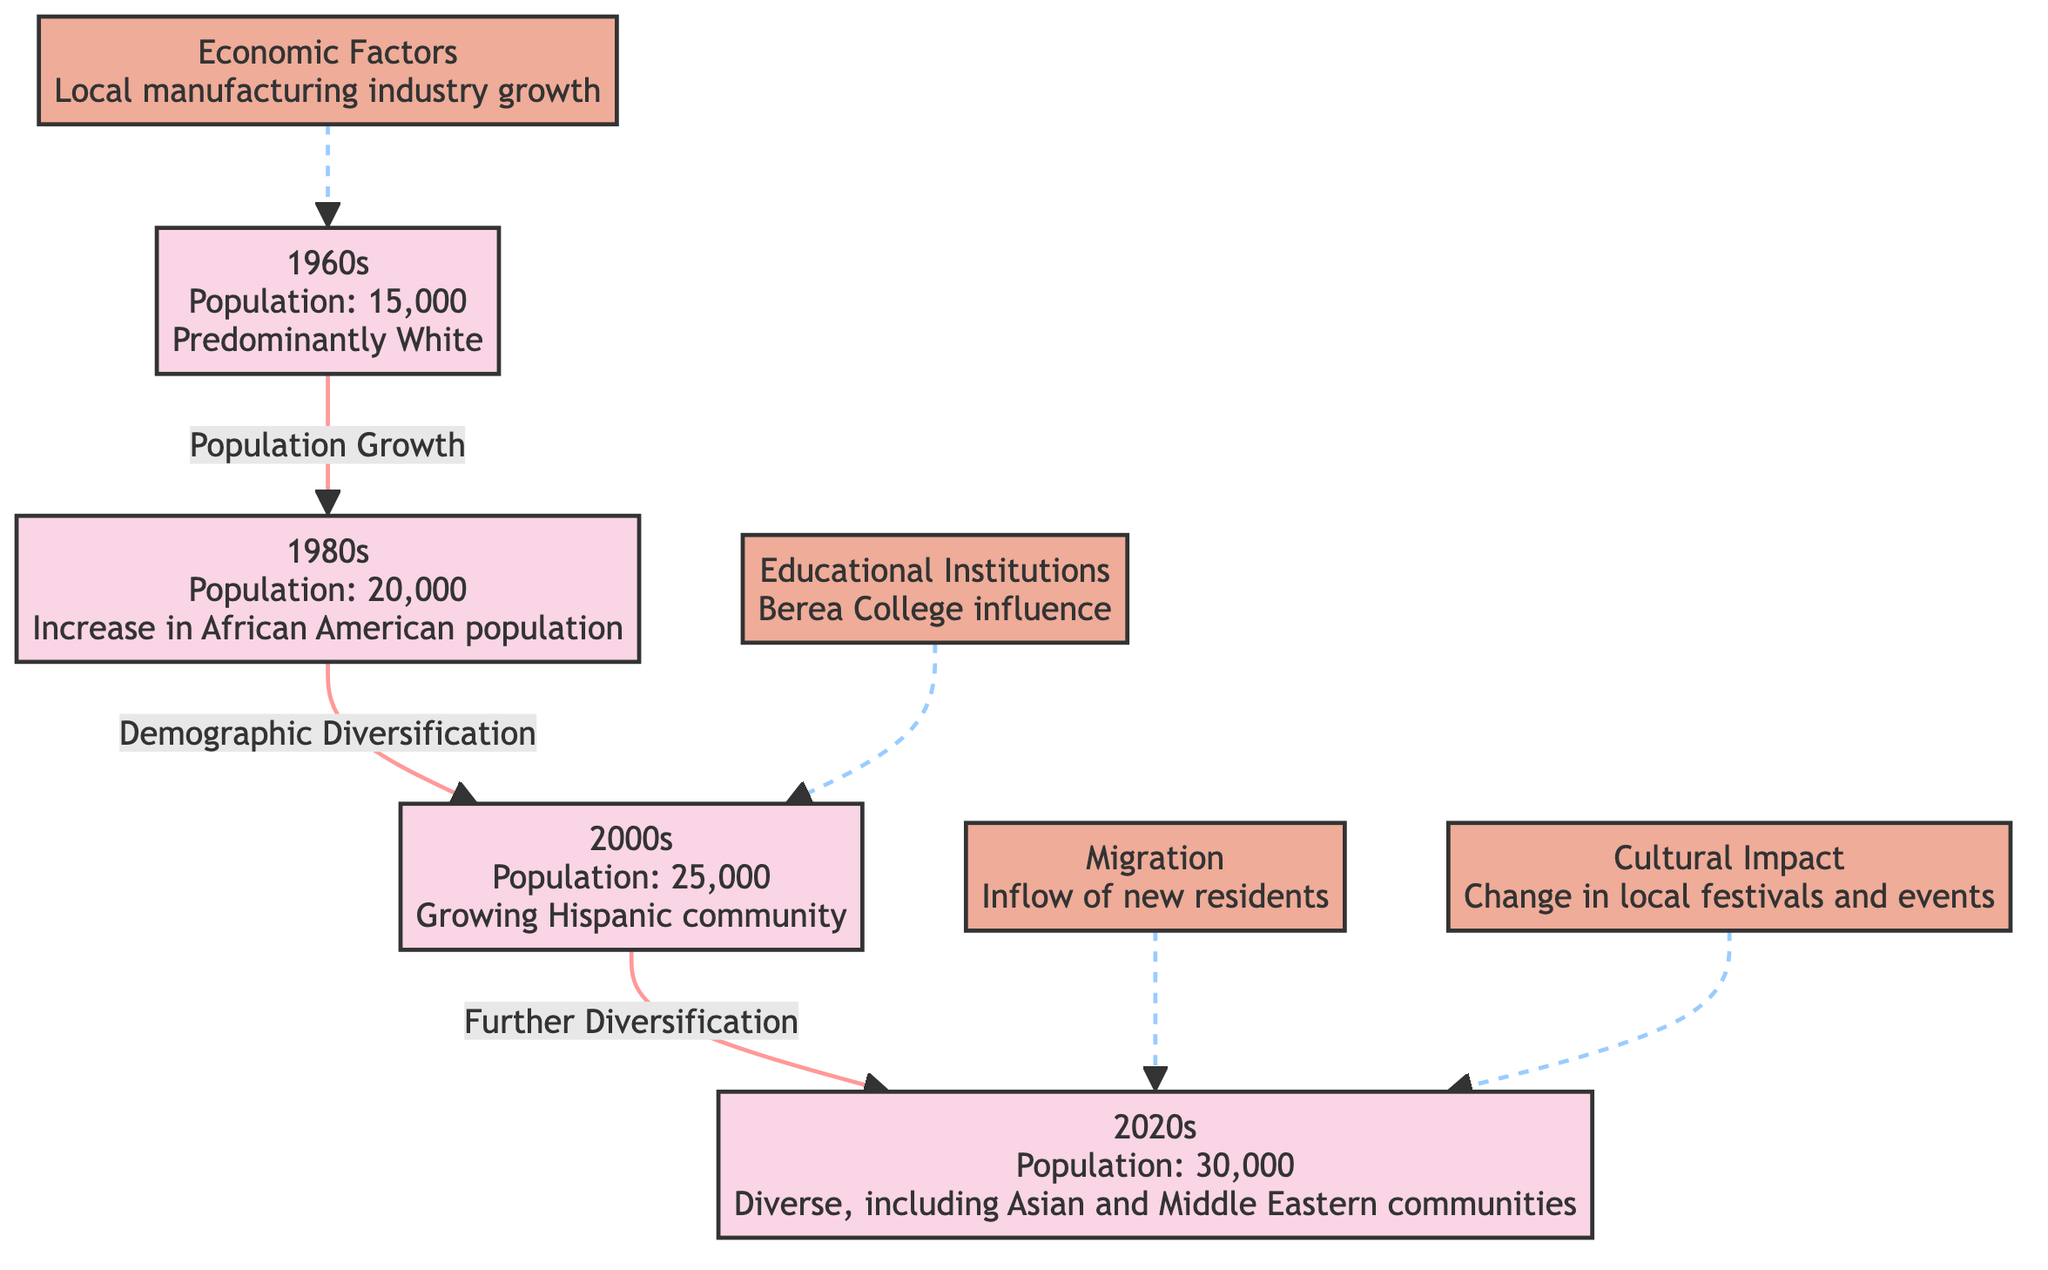What was the population of Berea in the 1980s? According to the diagram, the population specified for the 1980s is 20,000. This information is directly stated within the node for the 1980s.
Answer: 20,000 What demographic change is noted from the 1960s to the 1980s? The diagram highlights an "Increase in African American population" as the main demographic change between the 1960s and the 1980s. This is indicated as a descriptive relationship in the flow.
Answer: Increase in African American population Which decade showed a growing Hispanic community? The node for the 2000s specifically states, "Growing Hispanic community," making it clear that this demographic feature is noted in that period.
Answer: 2000s How many decades are represented in the diagram? The diagram contains four decades represented: the 1960s, 1980s, 2000s, and 2020s. Counting each distinctive decade indicated by the nodes shows this total.
Answer: Four What effect did educational institutions have in the 2000s according to the diagram? The diagram states that educational institutions, particularly Berea College, had an influence in the 2000s. This is visually represented by a dashed line pointing towards the 2000s node.
Answer: Berea College influence How does migration impact Berea in the 2020s? The diagram indicates that migration has led to "Inflow of new residents" in the 2020s, suggesting that it plays a notable role in the demographic shifts of that time period.
Answer: Inflow of new residents What type of impact does culture have in the 2020s? The diagram illustrates that culture has led to a change in local festivals and events, demonstrating its influence during the 2020s. This descriptive relationship is highlighted with a dashed line.
Answer: Change in local festivals and events What is the main economic factor noted for the 1960s? The node for the 1960s indicates "Local manufacturing industry growth" as the main economic factor affecting that period. This is directly stated within the node.
Answer: Local manufacturing industry growth Which decade demonstrates the highest population? From the diagram, the 2020s shows the highest population at 30,000, indicating a progression in numbers over the decades. This is shown clearly in the diagram's nodes.
Answer: 30,000 